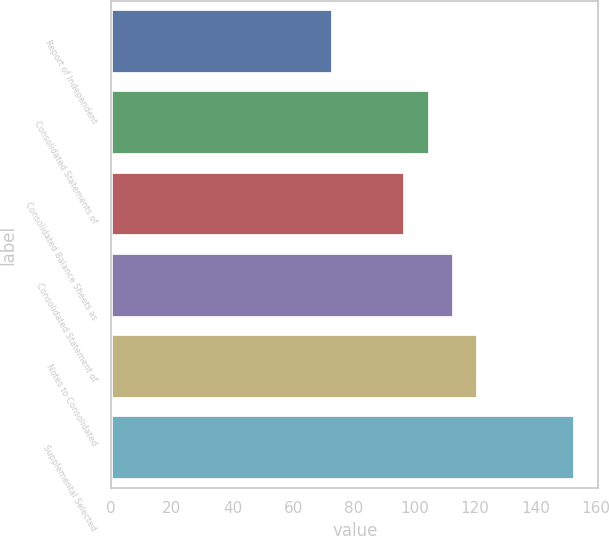Convert chart. <chart><loc_0><loc_0><loc_500><loc_500><bar_chart><fcel>Report of Independent<fcel>Consolidated Statements of<fcel>Consolidated Balance Sheets as<fcel>Consolidated Statement of<fcel>Notes to Consolidated<fcel>Supplemental Selected<nl><fcel>73<fcel>105<fcel>97<fcel>113<fcel>121<fcel>153<nl></chart> 